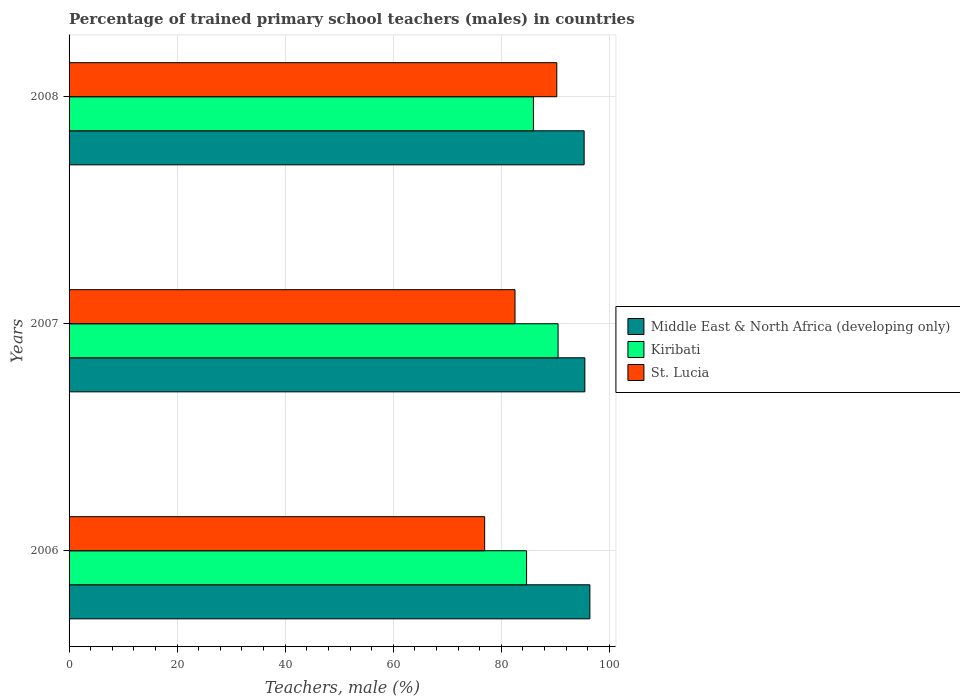How many different coloured bars are there?
Your response must be concise. 3. Are the number of bars per tick equal to the number of legend labels?
Offer a very short reply. Yes. Are the number of bars on each tick of the Y-axis equal?
Provide a succinct answer. Yes. How many bars are there on the 3rd tick from the top?
Offer a terse response. 3. How many bars are there on the 2nd tick from the bottom?
Make the answer very short. 3. What is the label of the 1st group of bars from the top?
Your answer should be compact. 2008. What is the percentage of trained primary school teachers (males) in Middle East & North Africa (developing only) in 2007?
Your answer should be very brief. 95.45. Across all years, what is the maximum percentage of trained primary school teachers (males) in St. Lucia?
Your answer should be compact. 90.26. Across all years, what is the minimum percentage of trained primary school teachers (males) in Middle East & North Africa (developing only)?
Ensure brevity in your answer.  95.32. In which year was the percentage of trained primary school teachers (males) in Middle East & North Africa (developing only) maximum?
Make the answer very short. 2006. What is the total percentage of trained primary school teachers (males) in St. Lucia in the graph?
Offer a terse response. 249.69. What is the difference between the percentage of trained primary school teachers (males) in Middle East & North Africa (developing only) in 2006 and that in 2007?
Your answer should be very brief. 0.93. What is the difference between the percentage of trained primary school teachers (males) in Middle East & North Africa (developing only) in 2008 and the percentage of trained primary school teachers (males) in Kiribati in 2007?
Ensure brevity in your answer.  4.82. What is the average percentage of trained primary school teachers (males) in St. Lucia per year?
Provide a succinct answer. 83.23. In the year 2007, what is the difference between the percentage of trained primary school teachers (males) in Kiribati and percentage of trained primary school teachers (males) in Middle East & North Africa (developing only)?
Keep it short and to the point. -4.95. In how many years, is the percentage of trained primary school teachers (males) in St. Lucia greater than 92 %?
Provide a short and direct response. 0. What is the ratio of the percentage of trained primary school teachers (males) in Middle East & North Africa (developing only) in 2006 to that in 2008?
Provide a short and direct response. 1.01. Is the difference between the percentage of trained primary school teachers (males) in Kiribati in 2006 and 2008 greater than the difference between the percentage of trained primary school teachers (males) in Middle East & North Africa (developing only) in 2006 and 2008?
Your answer should be compact. No. What is the difference between the highest and the second highest percentage of trained primary school teachers (males) in Middle East & North Africa (developing only)?
Your response must be concise. 0.93. What is the difference between the highest and the lowest percentage of trained primary school teachers (males) in Kiribati?
Offer a very short reply. 5.83. Is the sum of the percentage of trained primary school teachers (males) in Middle East & North Africa (developing only) in 2007 and 2008 greater than the maximum percentage of trained primary school teachers (males) in Kiribati across all years?
Ensure brevity in your answer.  Yes. What does the 1st bar from the top in 2007 represents?
Provide a short and direct response. St. Lucia. What does the 3rd bar from the bottom in 2006 represents?
Ensure brevity in your answer.  St. Lucia. Is it the case that in every year, the sum of the percentage of trained primary school teachers (males) in St. Lucia and percentage of trained primary school teachers (males) in Middle East & North Africa (developing only) is greater than the percentage of trained primary school teachers (males) in Kiribati?
Give a very brief answer. Yes. How many bars are there?
Offer a very short reply. 9. Are all the bars in the graph horizontal?
Provide a short and direct response. Yes. How many years are there in the graph?
Ensure brevity in your answer.  3. What is the difference between two consecutive major ticks on the X-axis?
Offer a terse response. 20. Does the graph contain grids?
Offer a very short reply. Yes. What is the title of the graph?
Provide a succinct answer. Percentage of trained primary school teachers (males) in countries. Does "Korea (Republic)" appear as one of the legend labels in the graph?
Provide a short and direct response. No. What is the label or title of the X-axis?
Your response must be concise. Teachers, male (%). What is the Teachers, male (%) in Middle East & North Africa (developing only) in 2006?
Offer a very short reply. 96.38. What is the Teachers, male (%) of Kiribati in 2006?
Give a very brief answer. 84.66. What is the Teachers, male (%) in St. Lucia in 2006?
Offer a terse response. 76.91. What is the Teachers, male (%) in Middle East & North Africa (developing only) in 2007?
Offer a very short reply. 95.45. What is the Teachers, male (%) of Kiribati in 2007?
Give a very brief answer. 90.5. What is the Teachers, male (%) in St. Lucia in 2007?
Your answer should be very brief. 82.53. What is the Teachers, male (%) of Middle East & North Africa (developing only) in 2008?
Offer a very short reply. 95.32. What is the Teachers, male (%) in Kiribati in 2008?
Give a very brief answer. 85.93. What is the Teachers, male (%) in St. Lucia in 2008?
Give a very brief answer. 90.26. Across all years, what is the maximum Teachers, male (%) in Middle East & North Africa (developing only)?
Offer a very short reply. 96.38. Across all years, what is the maximum Teachers, male (%) of Kiribati?
Ensure brevity in your answer.  90.5. Across all years, what is the maximum Teachers, male (%) of St. Lucia?
Offer a terse response. 90.26. Across all years, what is the minimum Teachers, male (%) of Middle East & North Africa (developing only)?
Provide a short and direct response. 95.32. Across all years, what is the minimum Teachers, male (%) in Kiribati?
Keep it short and to the point. 84.66. Across all years, what is the minimum Teachers, male (%) of St. Lucia?
Ensure brevity in your answer.  76.91. What is the total Teachers, male (%) in Middle East & North Africa (developing only) in the graph?
Your answer should be very brief. 287.14. What is the total Teachers, male (%) of Kiribati in the graph?
Offer a very short reply. 261.09. What is the total Teachers, male (%) of St. Lucia in the graph?
Your answer should be very brief. 249.69. What is the difference between the Teachers, male (%) in Middle East & North Africa (developing only) in 2006 and that in 2007?
Your answer should be very brief. 0.93. What is the difference between the Teachers, male (%) in Kiribati in 2006 and that in 2007?
Your answer should be very brief. -5.83. What is the difference between the Teachers, male (%) of St. Lucia in 2006 and that in 2007?
Offer a terse response. -5.62. What is the difference between the Teachers, male (%) in Middle East & North Africa (developing only) in 2006 and that in 2008?
Offer a terse response. 1.06. What is the difference between the Teachers, male (%) in Kiribati in 2006 and that in 2008?
Ensure brevity in your answer.  -1.27. What is the difference between the Teachers, male (%) in St. Lucia in 2006 and that in 2008?
Ensure brevity in your answer.  -13.36. What is the difference between the Teachers, male (%) of Middle East & North Africa (developing only) in 2007 and that in 2008?
Give a very brief answer. 0.13. What is the difference between the Teachers, male (%) of Kiribati in 2007 and that in 2008?
Make the answer very short. 4.56. What is the difference between the Teachers, male (%) in St. Lucia in 2007 and that in 2008?
Provide a succinct answer. -7.73. What is the difference between the Teachers, male (%) in Middle East & North Africa (developing only) in 2006 and the Teachers, male (%) in Kiribati in 2007?
Offer a very short reply. 5.88. What is the difference between the Teachers, male (%) of Middle East & North Africa (developing only) in 2006 and the Teachers, male (%) of St. Lucia in 2007?
Keep it short and to the point. 13.85. What is the difference between the Teachers, male (%) in Kiribati in 2006 and the Teachers, male (%) in St. Lucia in 2007?
Keep it short and to the point. 2.14. What is the difference between the Teachers, male (%) of Middle East & North Africa (developing only) in 2006 and the Teachers, male (%) of Kiribati in 2008?
Give a very brief answer. 10.45. What is the difference between the Teachers, male (%) in Middle East & North Africa (developing only) in 2006 and the Teachers, male (%) in St. Lucia in 2008?
Your answer should be compact. 6.12. What is the difference between the Teachers, male (%) of Kiribati in 2006 and the Teachers, male (%) of St. Lucia in 2008?
Your answer should be very brief. -5.6. What is the difference between the Teachers, male (%) of Middle East & North Africa (developing only) in 2007 and the Teachers, male (%) of Kiribati in 2008?
Provide a succinct answer. 9.51. What is the difference between the Teachers, male (%) of Middle East & North Africa (developing only) in 2007 and the Teachers, male (%) of St. Lucia in 2008?
Your answer should be compact. 5.19. What is the difference between the Teachers, male (%) of Kiribati in 2007 and the Teachers, male (%) of St. Lucia in 2008?
Your answer should be very brief. 0.23. What is the average Teachers, male (%) of Middle East & North Africa (developing only) per year?
Make the answer very short. 95.71. What is the average Teachers, male (%) of Kiribati per year?
Your answer should be very brief. 87.03. What is the average Teachers, male (%) of St. Lucia per year?
Offer a terse response. 83.23. In the year 2006, what is the difference between the Teachers, male (%) in Middle East & North Africa (developing only) and Teachers, male (%) in Kiribati?
Your answer should be compact. 11.71. In the year 2006, what is the difference between the Teachers, male (%) in Middle East & North Africa (developing only) and Teachers, male (%) in St. Lucia?
Your answer should be very brief. 19.47. In the year 2006, what is the difference between the Teachers, male (%) of Kiribati and Teachers, male (%) of St. Lucia?
Your answer should be compact. 7.76. In the year 2007, what is the difference between the Teachers, male (%) in Middle East & North Africa (developing only) and Teachers, male (%) in Kiribati?
Your response must be concise. 4.95. In the year 2007, what is the difference between the Teachers, male (%) in Middle East & North Africa (developing only) and Teachers, male (%) in St. Lucia?
Your response must be concise. 12.92. In the year 2007, what is the difference between the Teachers, male (%) of Kiribati and Teachers, male (%) of St. Lucia?
Make the answer very short. 7.97. In the year 2008, what is the difference between the Teachers, male (%) in Middle East & North Africa (developing only) and Teachers, male (%) in Kiribati?
Ensure brevity in your answer.  9.39. In the year 2008, what is the difference between the Teachers, male (%) in Middle East & North Africa (developing only) and Teachers, male (%) in St. Lucia?
Offer a terse response. 5.06. In the year 2008, what is the difference between the Teachers, male (%) of Kiribati and Teachers, male (%) of St. Lucia?
Keep it short and to the point. -4.33. What is the ratio of the Teachers, male (%) in Middle East & North Africa (developing only) in 2006 to that in 2007?
Offer a terse response. 1.01. What is the ratio of the Teachers, male (%) of Kiribati in 2006 to that in 2007?
Your answer should be very brief. 0.94. What is the ratio of the Teachers, male (%) of St. Lucia in 2006 to that in 2007?
Provide a succinct answer. 0.93. What is the ratio of the Teachers, male (%) in Middle East & North Africa (developing only) in 2006 to that in 2008?
Give a very brief answer. 1.01. What is the ratio of the Teachers, male (%) of Kiribati in 2006 to that in 2008?
Provide a short and direct response. 0.99. What is the ratio of the Teachers, male (%) in St. Lucia in 2006 to that in 2008?
Give a very brief answer. 0.85. What is the ratio of the Teachers, male (%) in Middle East & North Africa (developing only) in 2007 to that in 2008?
Offer a terse response. 1. What is the ratio of the Teachers, male (%) of Kiribati in 2007 to that in 2008?
Provide a short and direct response. 1.05. What is the ratio of the Teachers, male (%) in St. Lucia in 2007 to that in 2008?
Offer a terse response. 0.91. What is the difference between the highest and the second highest Teachers, male (%) of Middle East & North Africa (developing only)?
Ensure brevity in your answer.  0.93. What is the difference between the highest and the second highest Teachers, male (%) of Kiribati?
Offer a very short reply. 4.56. What is the difference between the highest and the second highest Teachers, male (%) of St. Lucia?
Your response must be concise. 7.73. What is the difference between the highest and the lowest Teachers, male (%) in Middle East & North Africa (developing only)?
Give a very brief answer. 1.06. What is the difference between the highest and the lowest Teachers, male (%) of Kiribati?
Offer a terse response. 5.83. What is the difference between the highest and the lowest Teachers, male (%) in St. Lucia?
Provide a succinct answer. 13.36. 